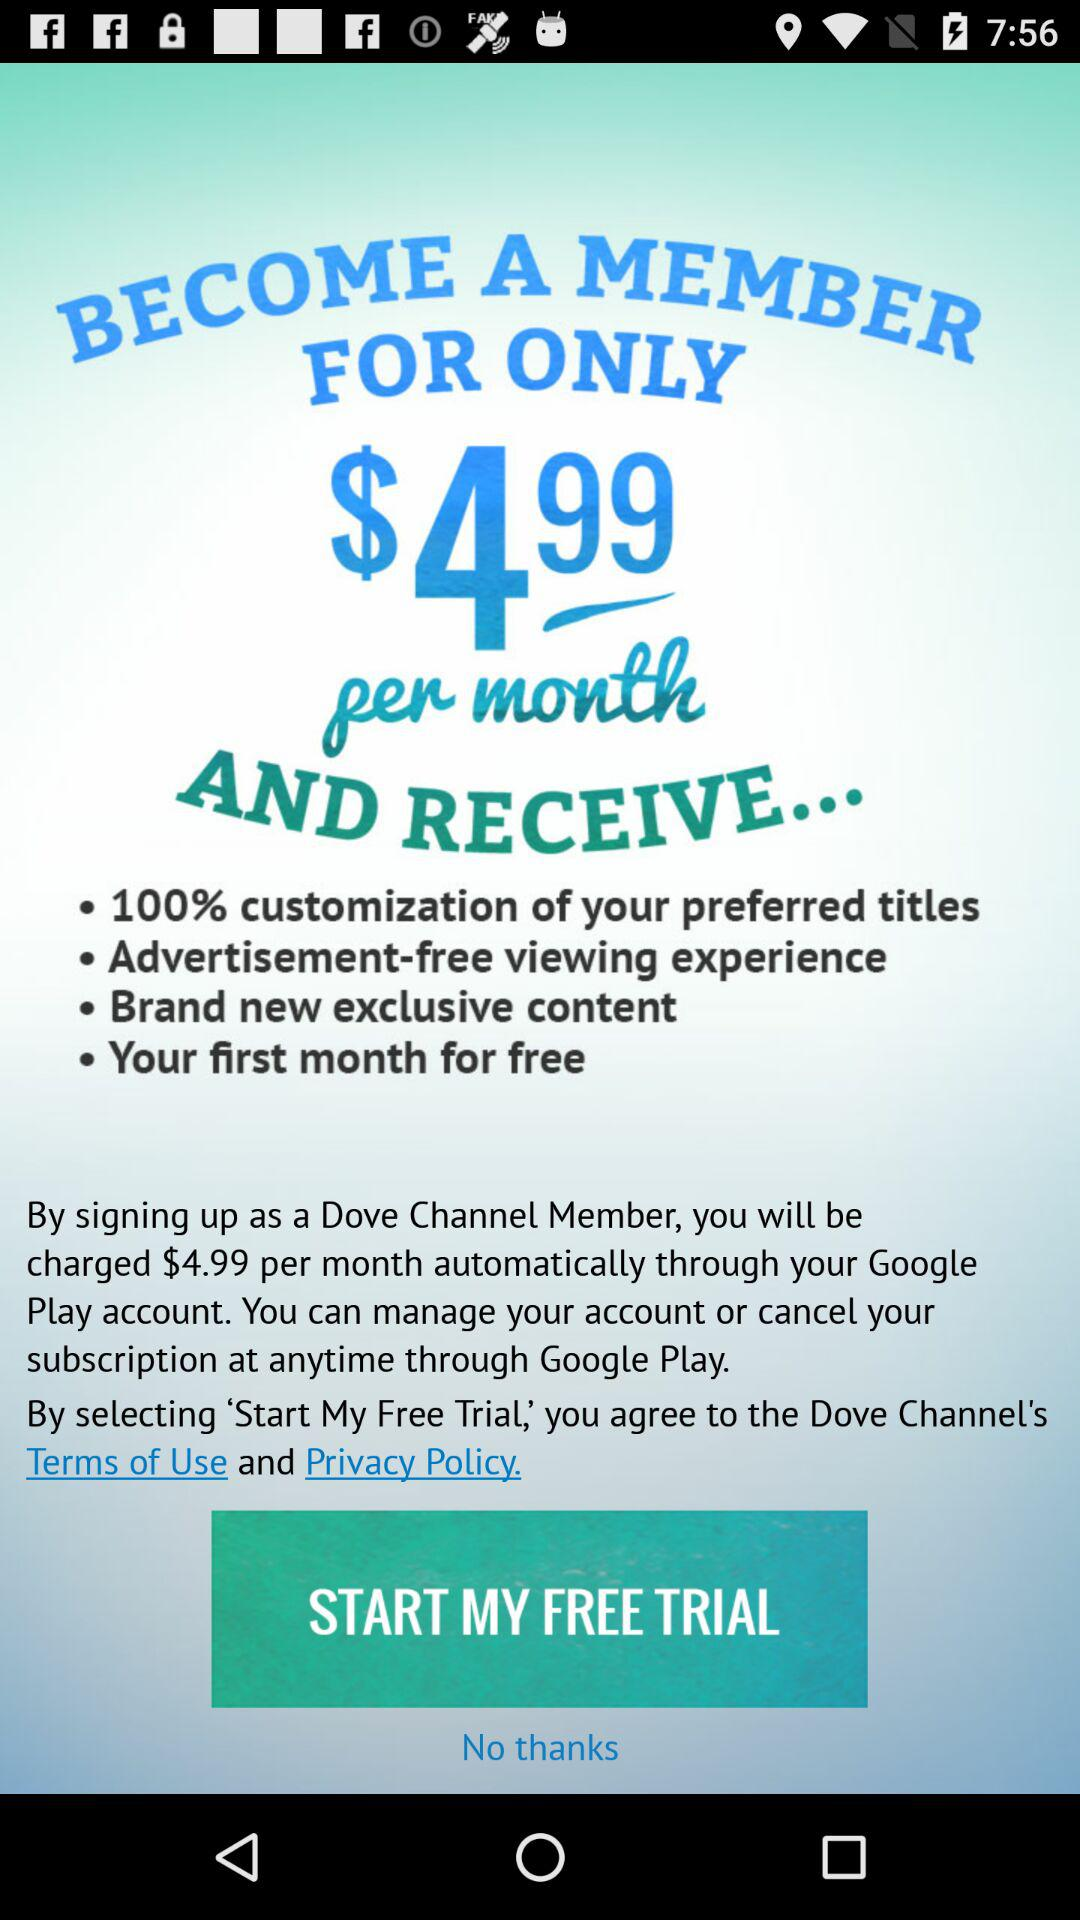How many free months are offered?
Answer the question using a single word or phrase. 1 